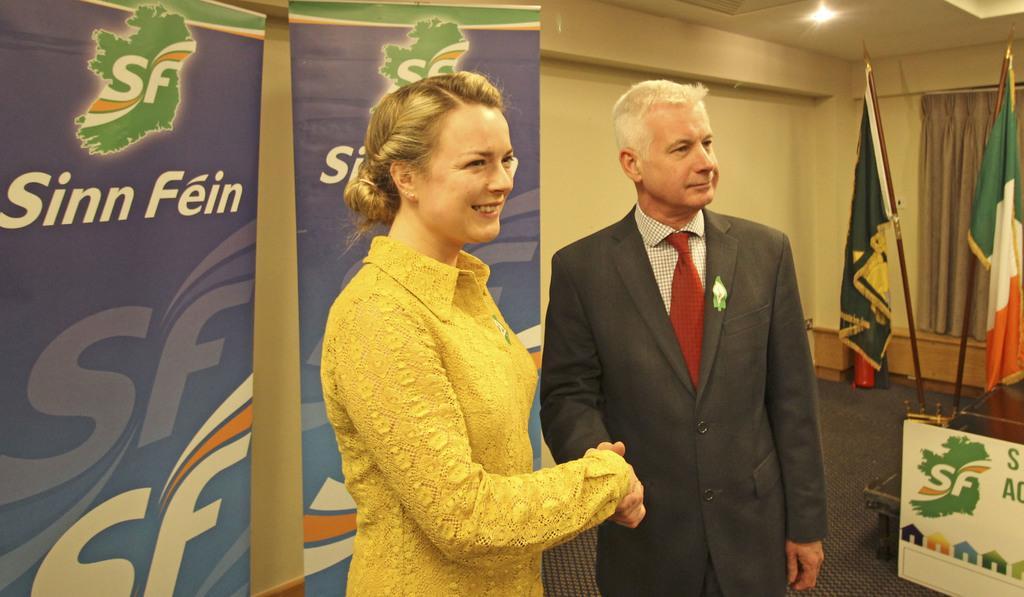Can you describe this image briefly? In this image I can see two persons shaking hands. In the background I can see two banners with some text on it. On the right side I can see two flags. I can see a curtain. At the top I can see a light. 